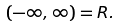<formula> <loc_0><loc_0><loc_500><loc_500>( - \infty , \infty ) = { R } .</formula> 